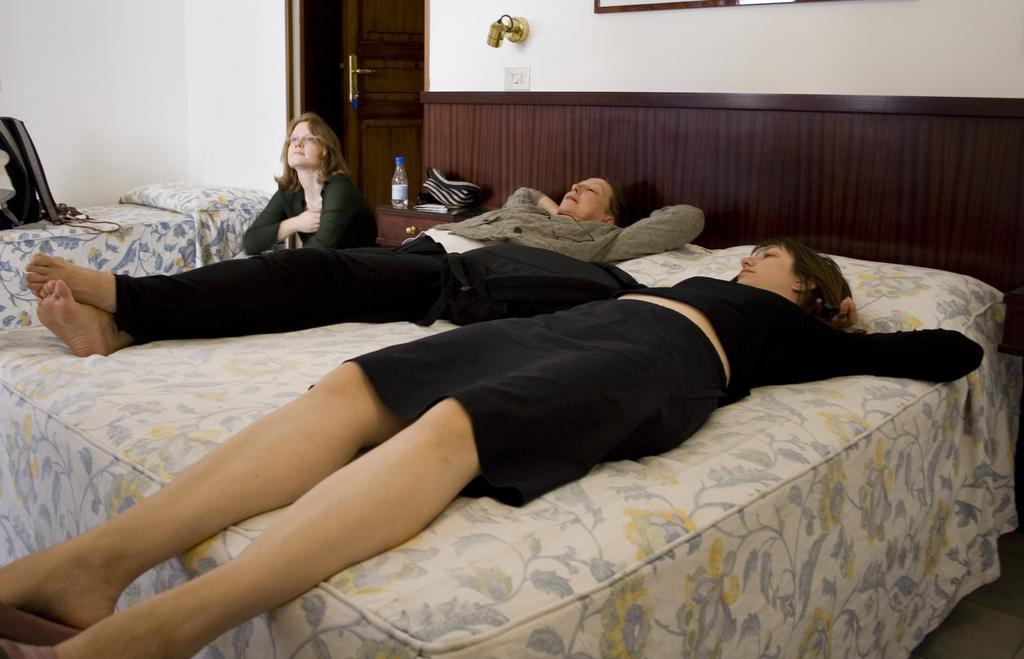What are the women in the foreground of the image doing? There are two women laying on the bed in the image. Can you describe the woman in the background? There is a woman sitting in the background of the image. What can be seen on the cupboard in the image? There is a bottle on a cupboard in the image. What type of structure is visible in the image? There is a wall visible in the image, and there is also a door present. What type of pollution can be seen in the image? There is no pollution visible in the image. Can you read the note that is on the bed? There is no note present on the bed in the image. 